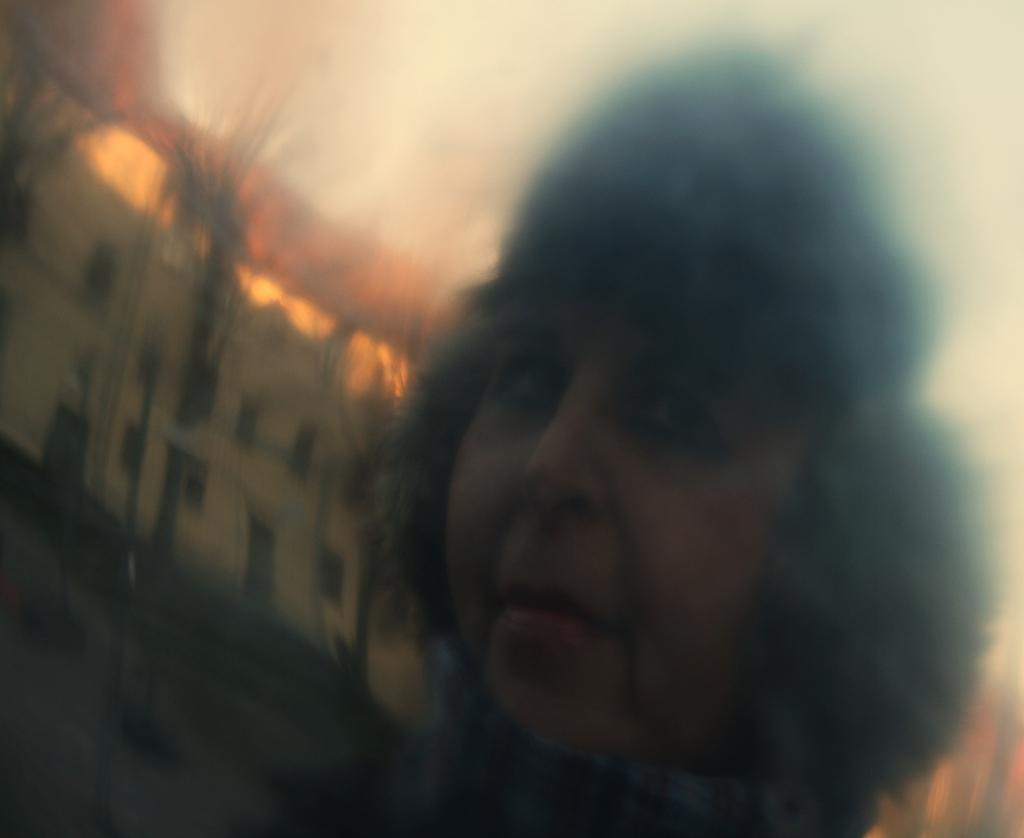What is the main subject of the image? There is a person in the image. Can you describe the setting of the image? There is a building in the background of the image. What type of religious symbol can be seen on the person's thumb in the image? There is no religious symbol or thumb visible on the person in the image. 